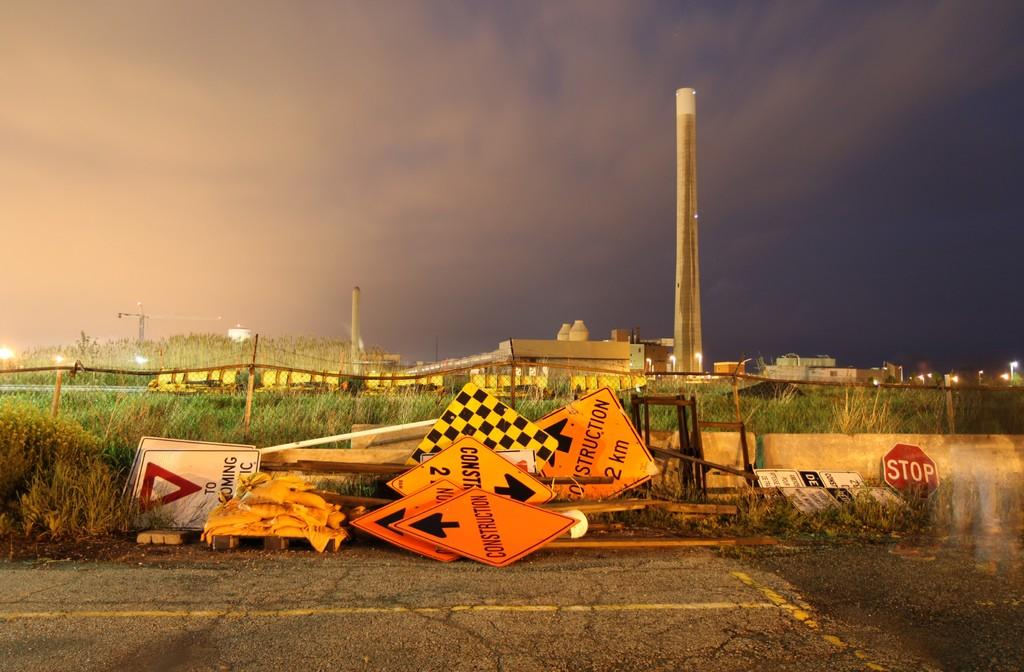<image>
Summarize the visual content of the image. many yield and construction signs are piled along side the road 